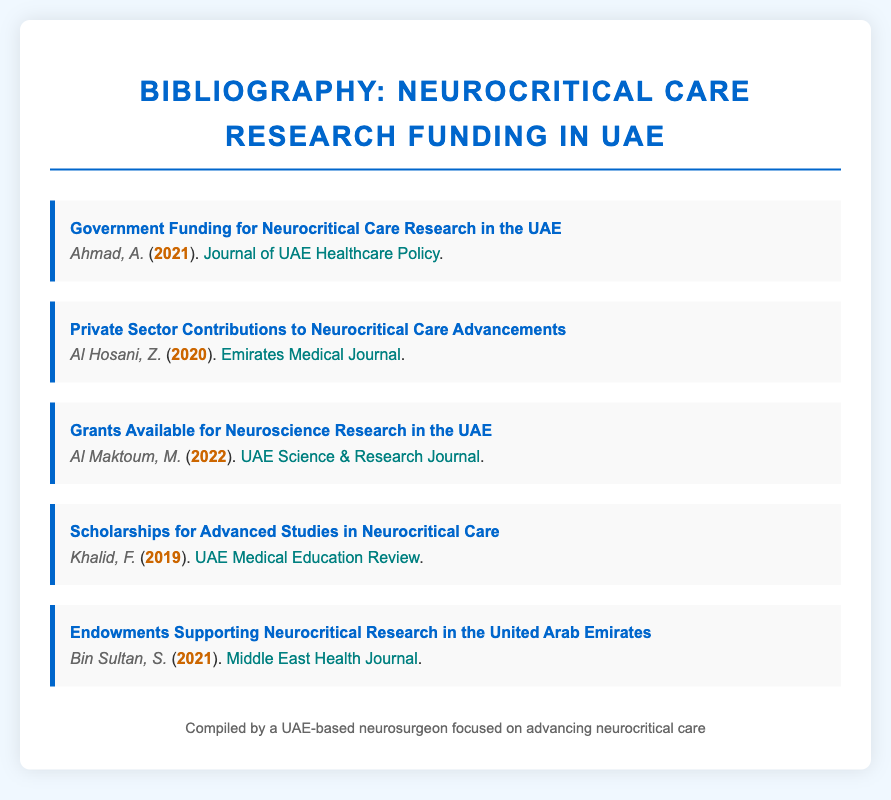What is the title of the first entry in the bibliography? The title of the first entry is “Government Funding for Neurocritical Care Research in the UAE.”
Answer: Government Funding for Neurocritical Care Research in the UAE Who authored the article on private sector contributions? The author of the article on private sector contributions is Al Hosani, Z.
Answer: Al Hosani, Z In which year was the article about scholarships published? The article about scholarships was published in 2019.
Answer: 2019 What is the publication name of the article authored by Al Maktoum, M.? The publication name of the article is "UAE Science & Research Journal."
Answer: UAE Science & Research Journal Which link leads to information about endowments? The link to information about endowments is "https://mehj.org/endowments-neurocritical-research-uae."
Answer: https://mehj.org/endowments-neurocritical-research-uae How many bibliography entries are there in total? There are five entries in total in the bibliography.
Answer: 5 What is the focus of the bibliography document? The focus of the bibliography document is on funding for neurocritical care research in the UAE.
Answer: funding for neurocritical care research in the UAE Which author contributed to the discussions on grants? The author who contributed to the discussions on grants is Al Maktoum, M.
Answer: Al Maktoum, M What is the primary purpose of the compiled bibliography? The primary purpose is to provide a list of resources related to neurocritical care research funding in the UAE.
Answer: provide a list of resources related to neurocritical care research funding in the UAE 